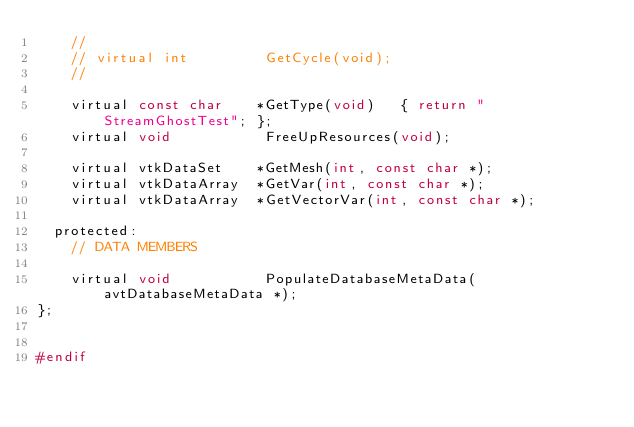Convert code to text. <code><loc_0><loc_0><loc_500><loc_500><_C_>    //
    // virtual int         GetCycle(void);
    //

    virtual const char    *GetType(void)   { return "StreamGhostTest"; };
    virtual void           FreeUpResources(void); 

    virtual vtkDataSet    *GetMesh(int, const char *);
    virtual vtkDataArray  *GetVar(int, const char *);
    virtual vtkDataArray  *GetVectorVar(int, const char *);

  protected:
    // DATA MEMBERS

    virtual void           PopulateDatabaseMetaData(avtDatabaseMetaData *);
};


#endif
</code> 